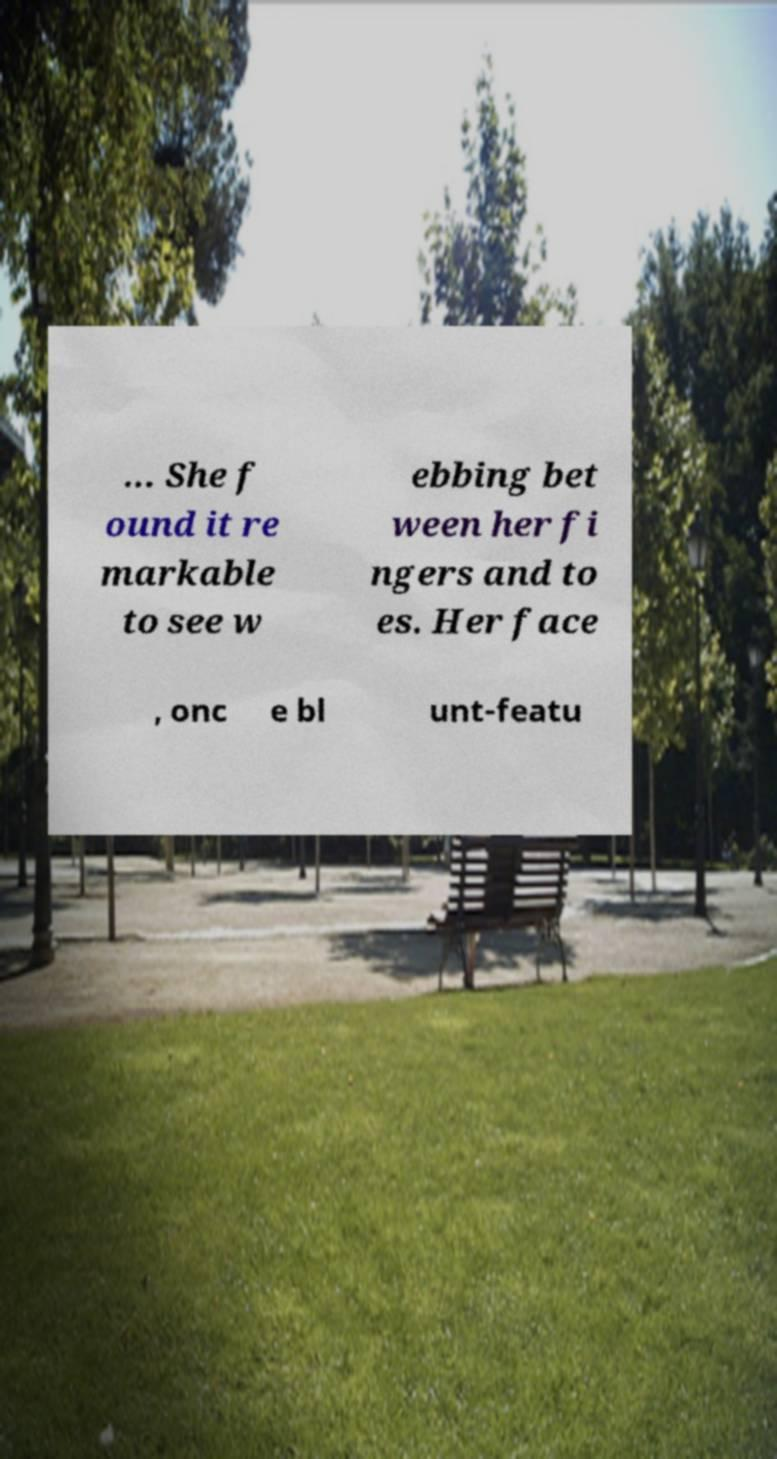Please read and relay the text visible in this image. What does it say? ... She f ound it re markable to see w ebbing bet ween her fi ngers and to es. Her face , onc e bl unt-featu 